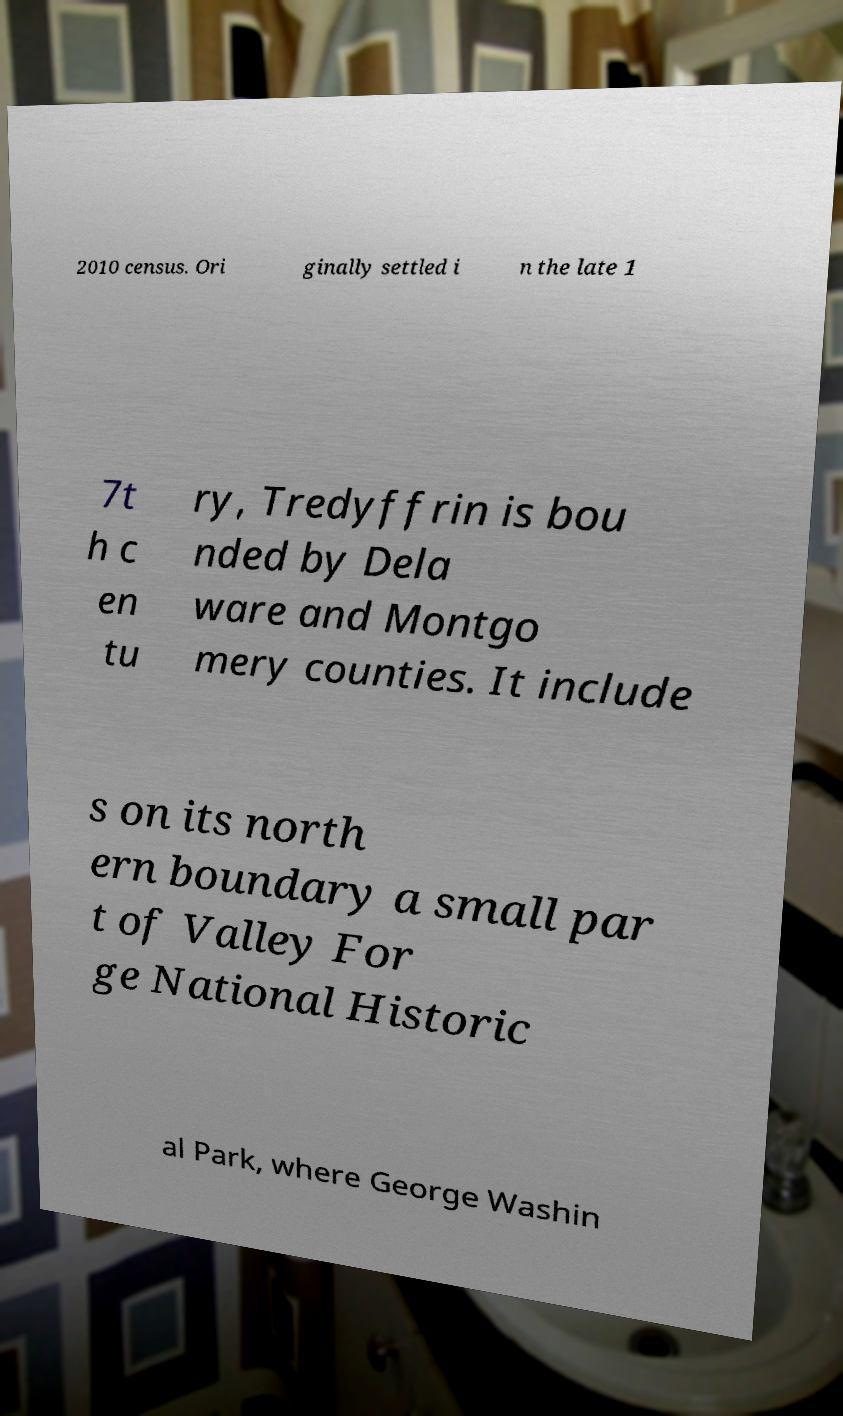What messages or text are displayed in this image? I need them in a readable, typed format. 2010 census. Ori ginally settled i n the late 1 7t h c en tu ry, Tredyffrin is bou nded by Dela ware and Montgo mery counties. It include s on its north ern boundary a small par t of Valley For ge National Historic al Park, where George Washin 